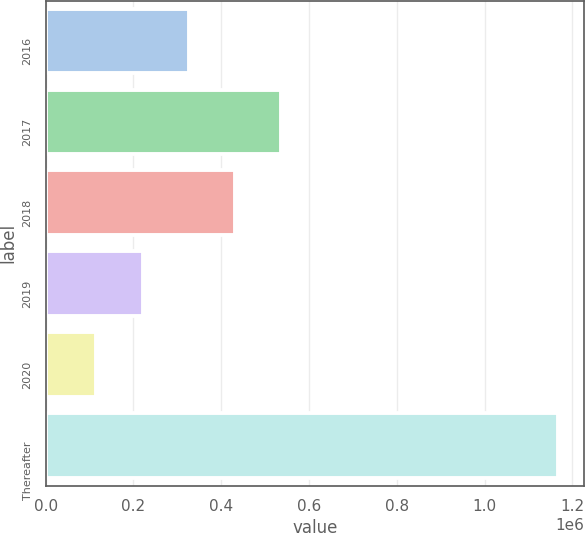Convert chart. <chart><loc_0><loc_0><loc_500><loc_500><bar_chart><fcel>2016<fcel>2017<fcel>2018<fcel>2019<fcel>2020<fcel>Thereafter<nl><fcel>325816<fcel>536201<fcel>431008<fcel>220623<fcel>115430<fcel>1.16736e+06<nl></chart> 